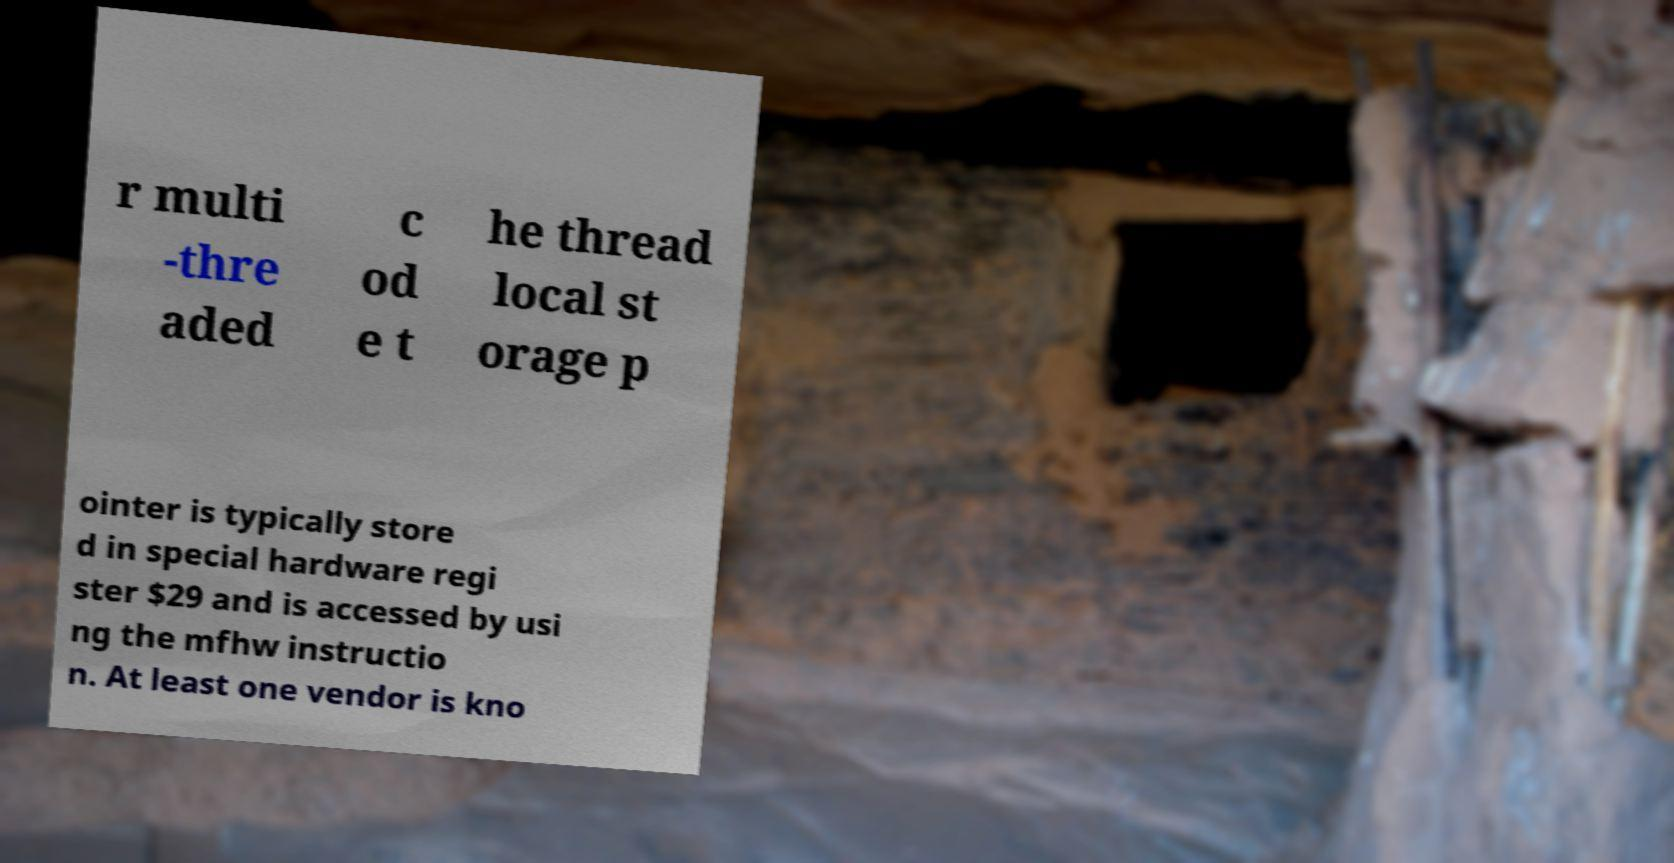Please read and relay the text visible in this image. What does it say? r multi -thre aded c od e t he thread local st orage p ointer is typically store d in special hardware regi ster $29 and is accessed by usi ng the mfhw instructio n. At least one vendor is kno 